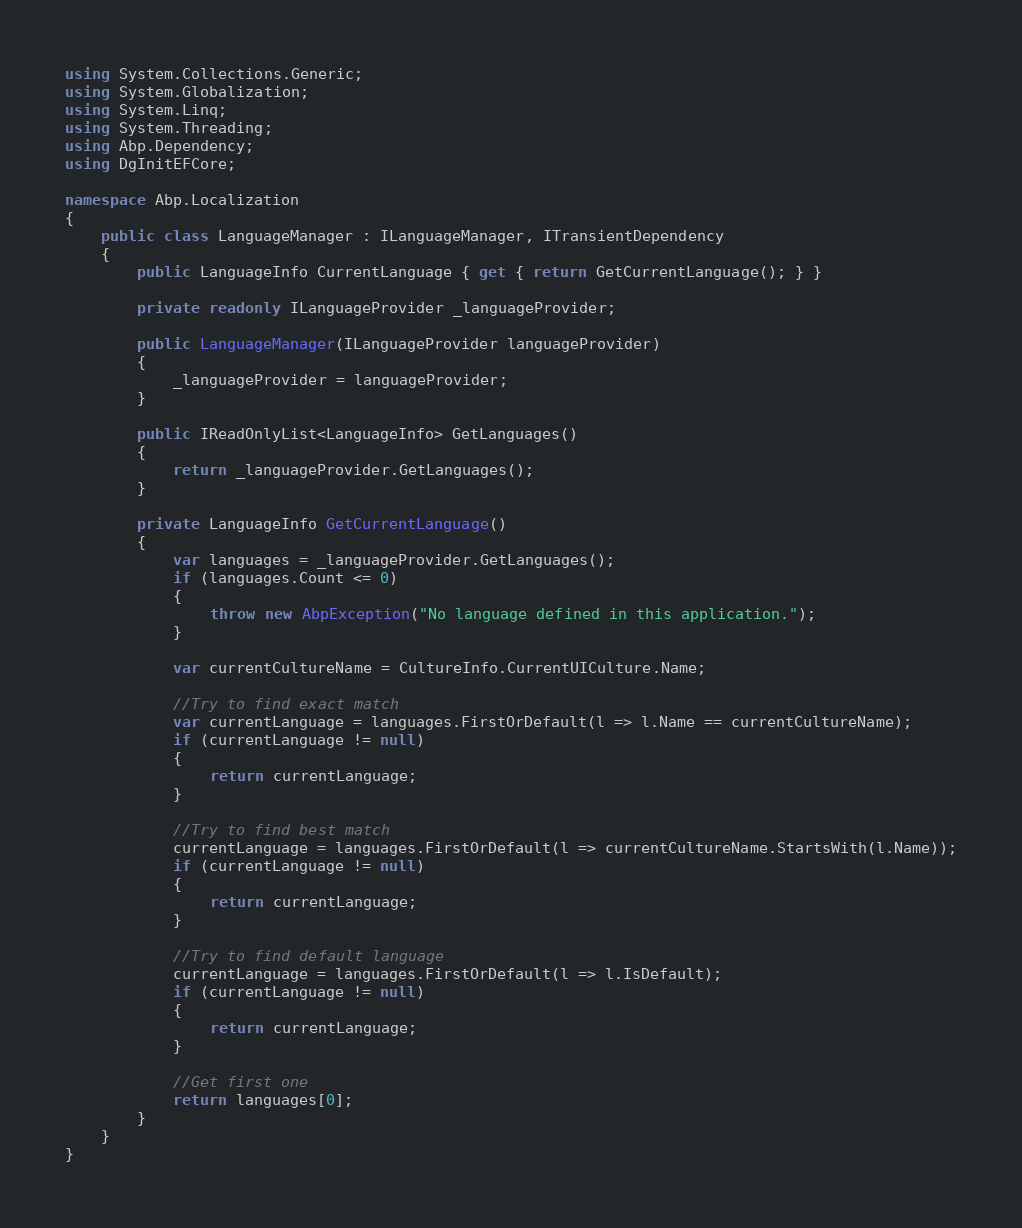Convert code to text. <code><loc_0><loc_0><loc_500><loc_500><_C#_>using System.Collections.Generic;
using System.Globalization;
using System.Linq;
using System.Threading;
using Abp.Dependency;
using DgInitEFCore;

namespace Abp.Localization
{
    public class LanguageManager : ILanguageManager, ITransientDependency
    {
        public LanguageInfo CurrentLanguage { get { return GetCurrentLanguage(); } }

        private readonly ILanguageProvider _languageProvider;

        public LanguageManager(ILanguageProvider languageProvider)
        {
            _languageProvider = languageProvider;
        }

        public IReadOnlyList<LanguageInfo> GetLanguages()
        {
            return _languageProvider.GetLanguages();
        }

        private LanguageInfo GetCurrentLanguage()
        {
            var languages = _languageProvider.GetLanguages();
            if (languages.Count <= 0)
            {
                throw new AbpException("No language defined in this application.");
            }

            var currentCultureName = CultureInfo.CurrentUICulture.Name;

            //Try to find exact match
            var currentLanguage = languages.FirstOrDefault(l => l.Name == currentCultureName);
            if (currentLanguage != null)
            {
                return currentLanguage;
            }

            //Try to find best match
            currentLanguage = languages.FirstOrDefault(l => currentCultureName.StartsWith(l.Name));
            if (currentLanguage != null)
            {
                return currentLanguage;
            }

            //Try to find default language
            currentLanguage = languages.FirstOrDefault(l => l.IsDefault);
            if (currentLanguage != null)
            {
                return currentLanguage;
            }

            //Get first one
            return languages[0];
        }
    }
}</code> 